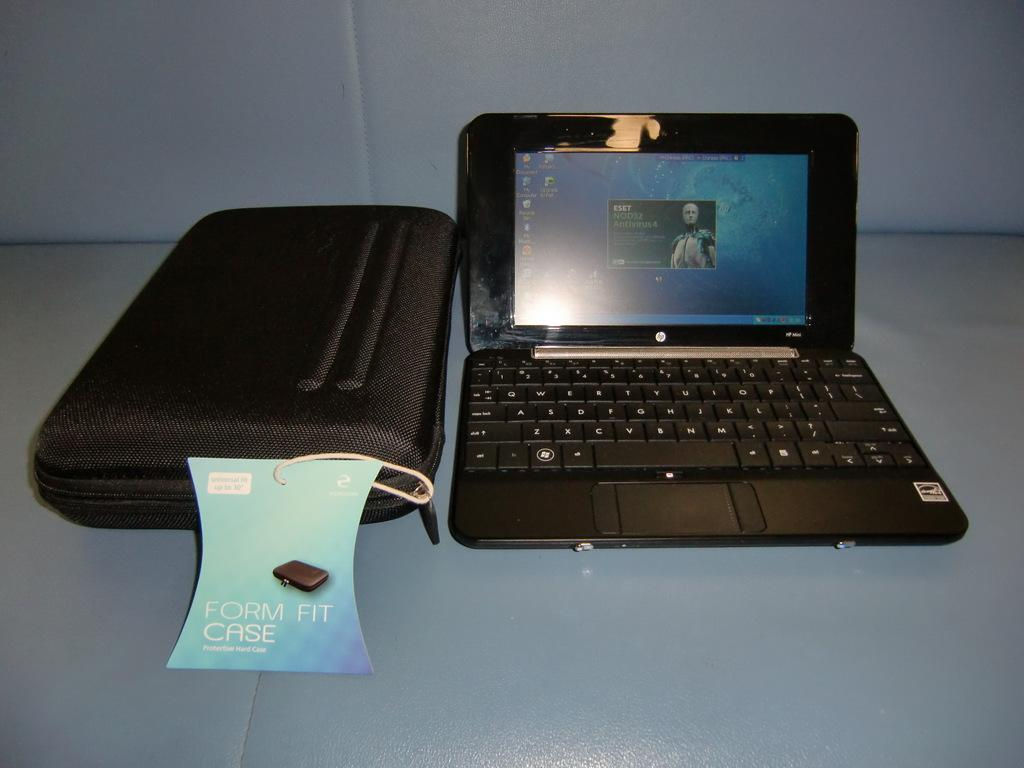<image>
Offer a succinct explanation of the picture presented. An old laptop and form fit case on a blue couch. 